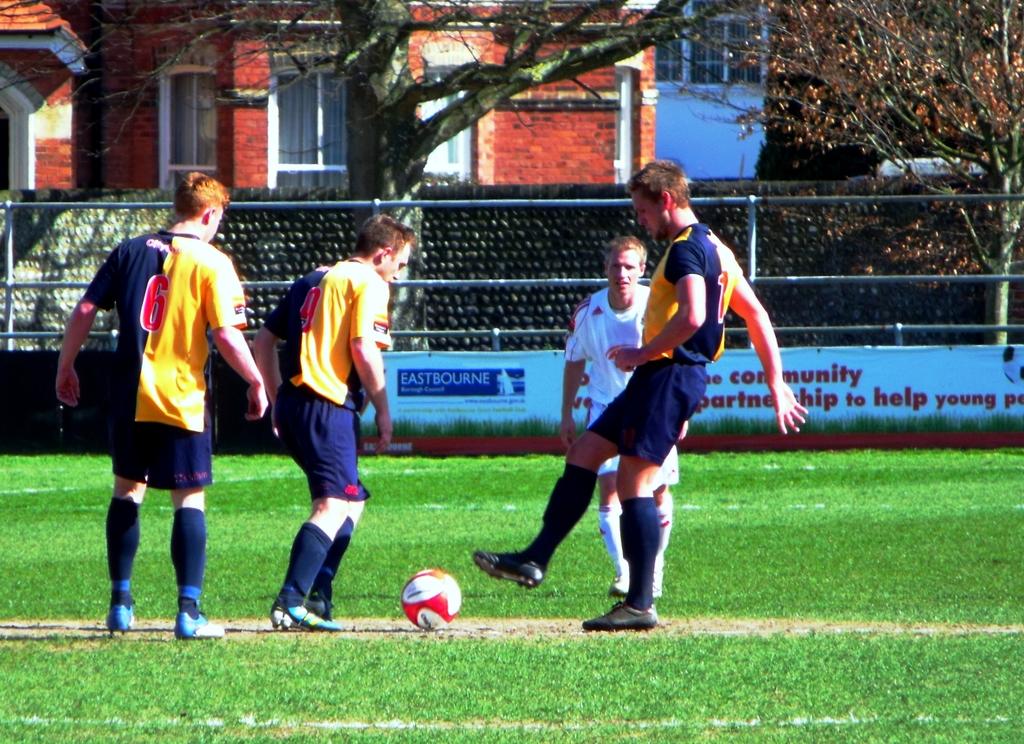What number is on the jersey of the man to the far left?
Give a very brief answer. 6. Does the sign in the back work to help young people?
Offer a terse response. Yes. 